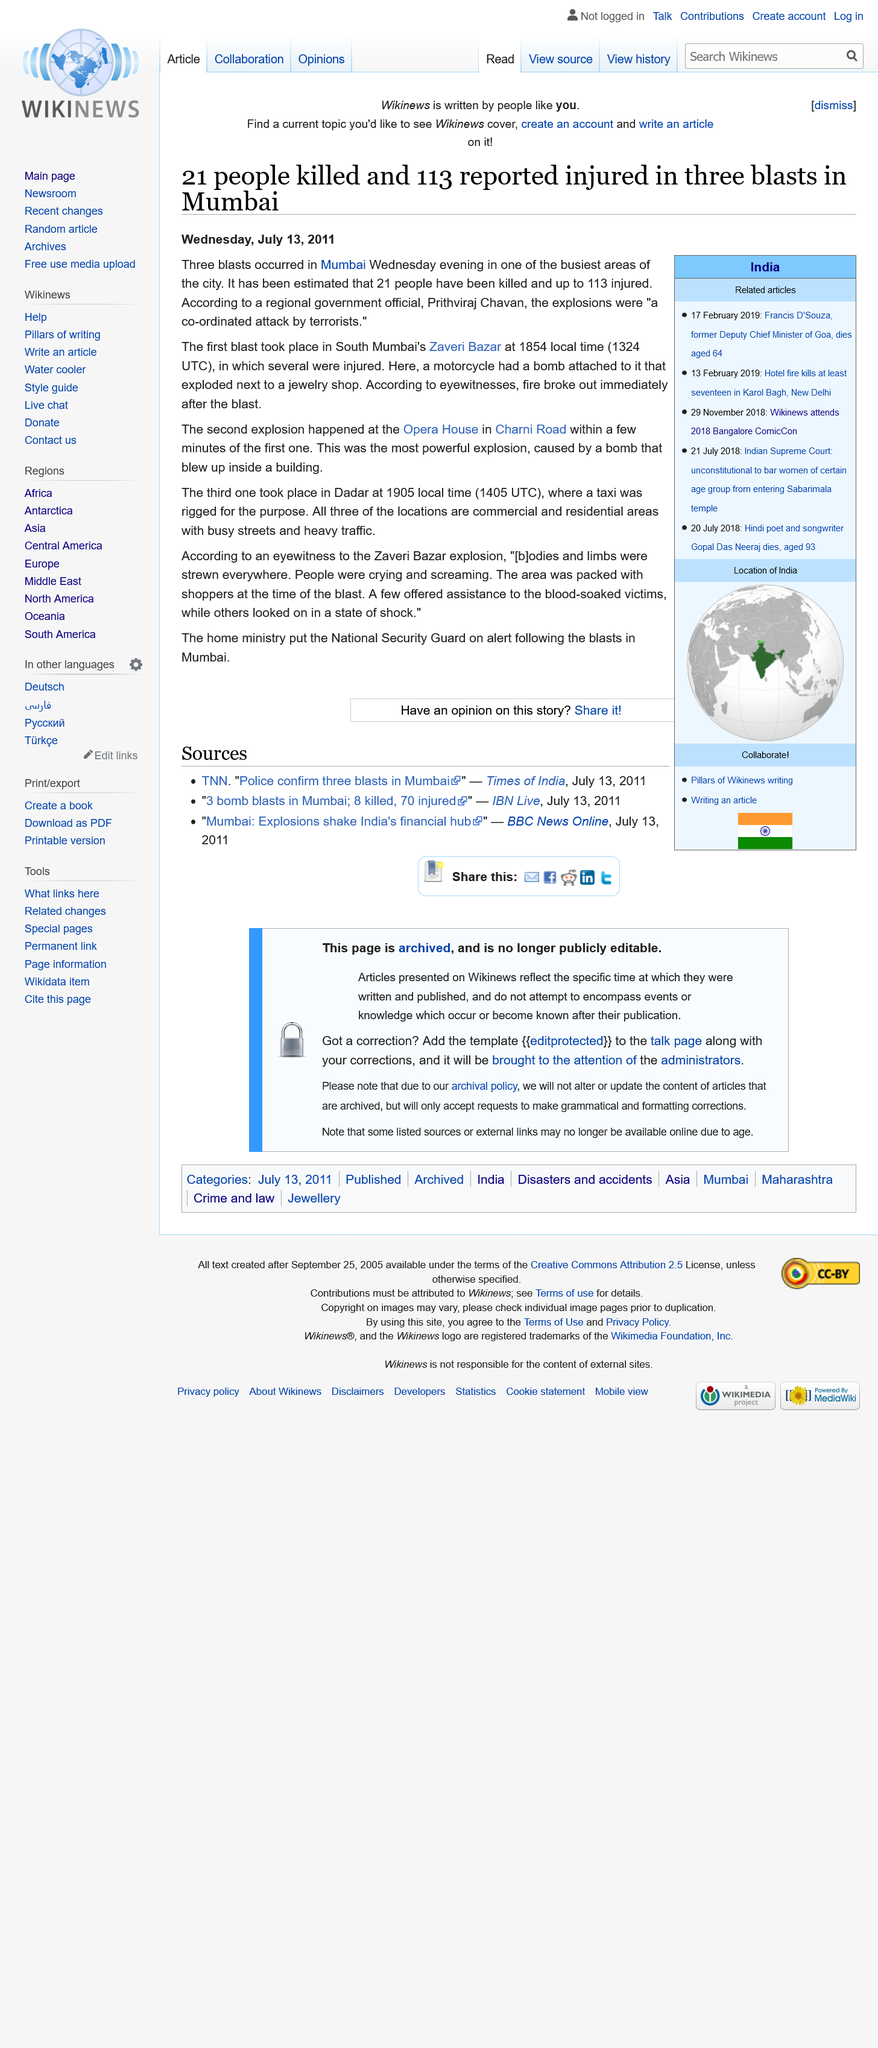Indicate a few pertinent items in this graphic. On Thursday evening, three blasts occurred in Mumbai, causing widespread panic and chaos. The home ministry alerted the National Security Guard following the blasts in Mumbai. There were three explosions in Mumbai, and the first one occurred in South Mumbai's Zaveri Bazar. 